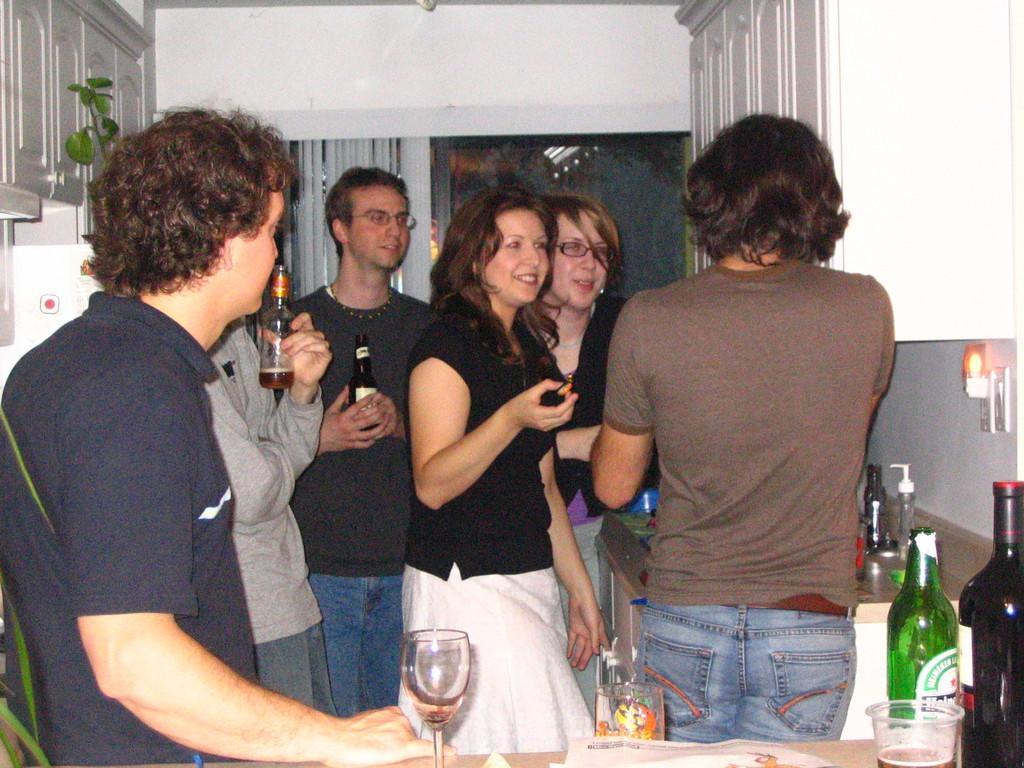Could you give a brief overview of what you see in this image? These group of people are standing inside this room. Middle this two persons are holding bottles and this two woman's are smiling wore black dress with white skirt. On this table there are bottles, papers and glasses with liquid. On top there are white cupboards. 